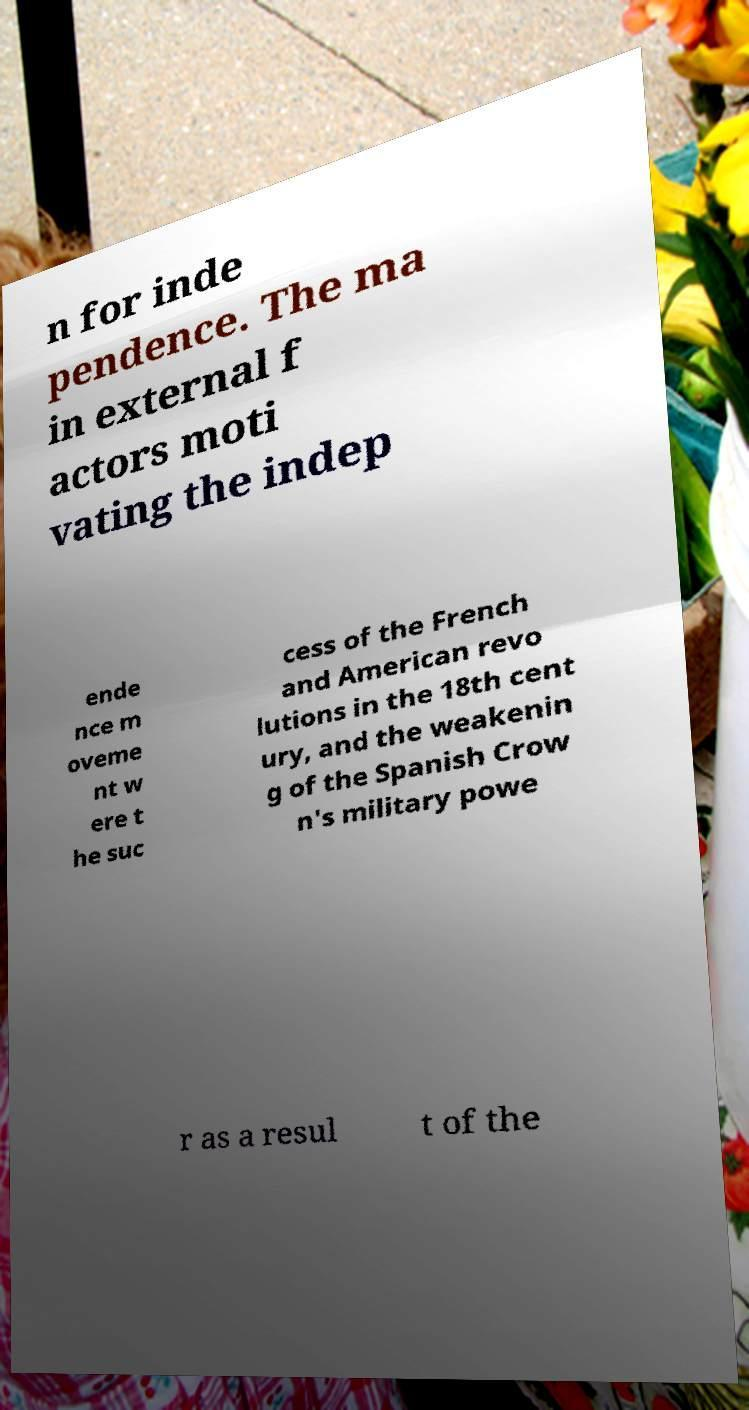Can you accurately transcribe the text from the provided image for me? n for inde pendence. The ma in external f actors moti vating the indep ende nce m oveme nt w ere t he suc cess of the French and American revo lutions in the 18th cent ury, and the weakenin g of the Spanish Crow n's military powe r as a resul t of the 